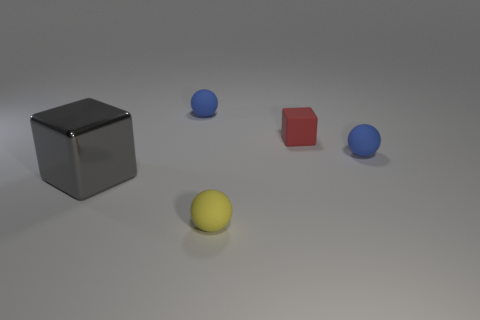There is a cube that is to the right of the gray thing; does it have the same size as the large gray metal thing?
Offer a very short reply. No. How big is the object that is both in front of the red matte object and on the left side of the small yellow rubber thing?
Give a very brief answer. Large. Do the metallic thing and the red thing that is behind the gray block have the same shape?
Your answer should be compact. Yes. How many objects are tiny blue balls on the left side of the yellow rubber object or tiny blue spheres that are to the left of the red rubber cube?
Your answer should be very brief. 1. Are there fewer yellow rubber balls that are behind the small yellow rubber ball than small blue matte objects?
Keep it short and to the point. Yes. Is the material of the gray cube the same as the thing that is in front of the gray metal cube?
Offer a very short reply. No. What material is the gray block?
Offer a terse response. Metal. The object left of the blue rubber ball behind the tiny red matte cube that is right of the yellow matte sphere is made of what material?
Ensure brevity in your answer.  Metal. There is a object that is left of the blue sphere that is left of the yellow ball; what is its color?
Keep it short and to the point. Gray. How many small blue rubber objects are there?
Your answer should be compact. 2. 